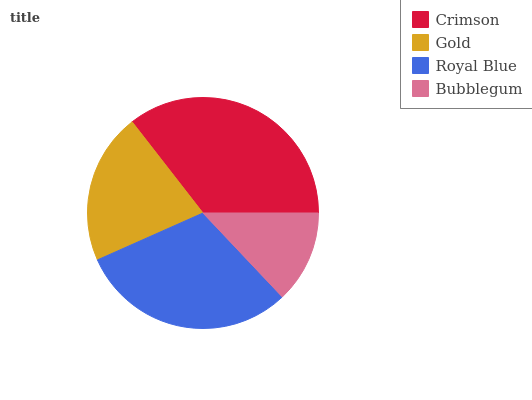Is Bubblegum the minimum?
Answer yes or no. Yes. Is Crimson the maximum?
Answer yes or no. Yes. Is Gold the minimum?
Answer yes or no. No. Is Gold the maximum?
Answer yes or no. No. Is Crimson greater than Gold?
Answer yes or no. Yes. Is Gold less than Crimson?
Answer yes or no. Yes. Is Gold greater than Crimson?
Answer yes or no. No. Is Crimson less than Gold?
Answer yes or no. No. Is Royal Blue the high median?
Answer yes or no. Yes. Is Gold the low median?
Answer yes or no. Yes. Is Gold the high median?
Answer yes or no. No. Is Bubblegum the low median?
Answer yes or no. No. 